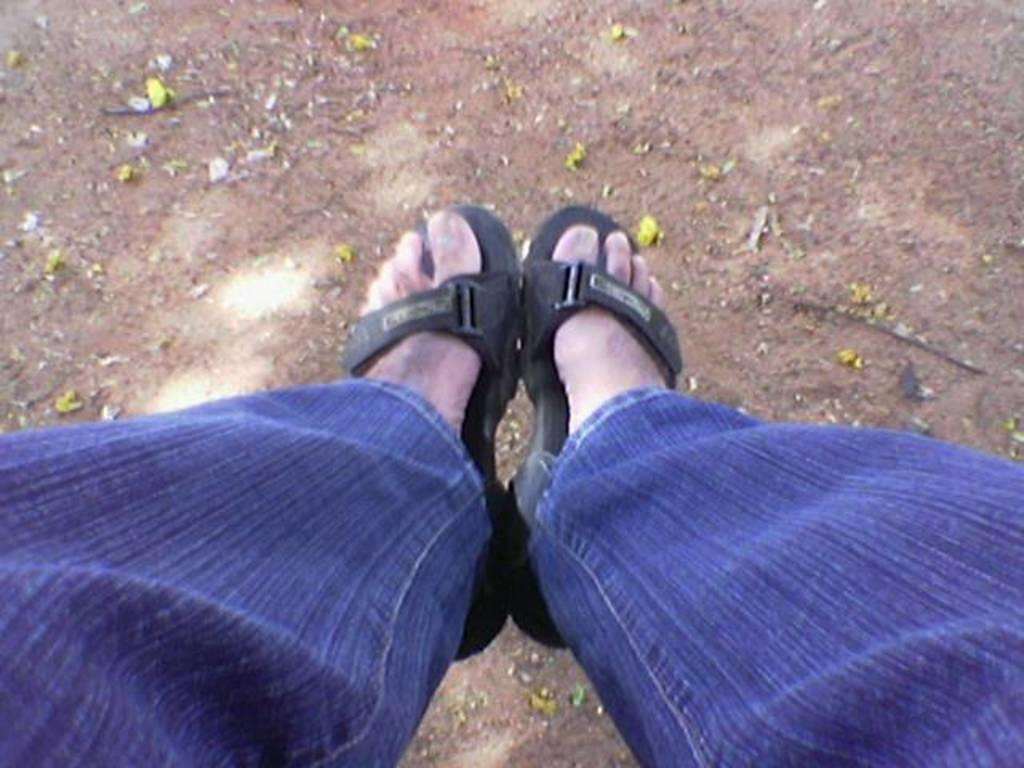What part of a person's body is visible in the image? There is a person's leg in the image. What type of clothing is the person wearing on their leg? The person is wearing blue jeans. What type of footwear is the person wearing? The person is wearing black sandals. What type of plant can be seen in the image? There is a yellow flower in the image. What is the condition of the road in the image? There is mud on the road in the image. What type of cheese is the person holding in the image? There is no cheese present in the image; the person is wearing black sandals and blue jeans. 